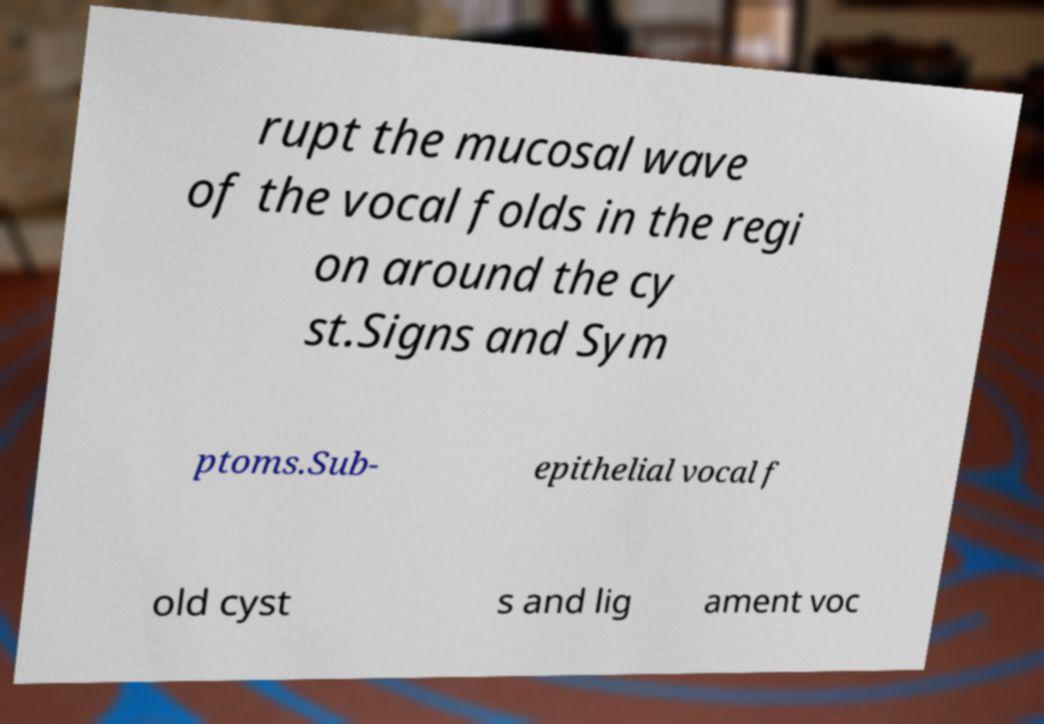Can you read and provide the text displayed in the image?This photo seems to have some interesting text. Can you extract and type it out for me? rupt the mucosal wave of the vocal folds in the regi on around the cy st.Signs and Sym ptoms.Sub- epithelial vocal f old cyst s and lig ament voc 